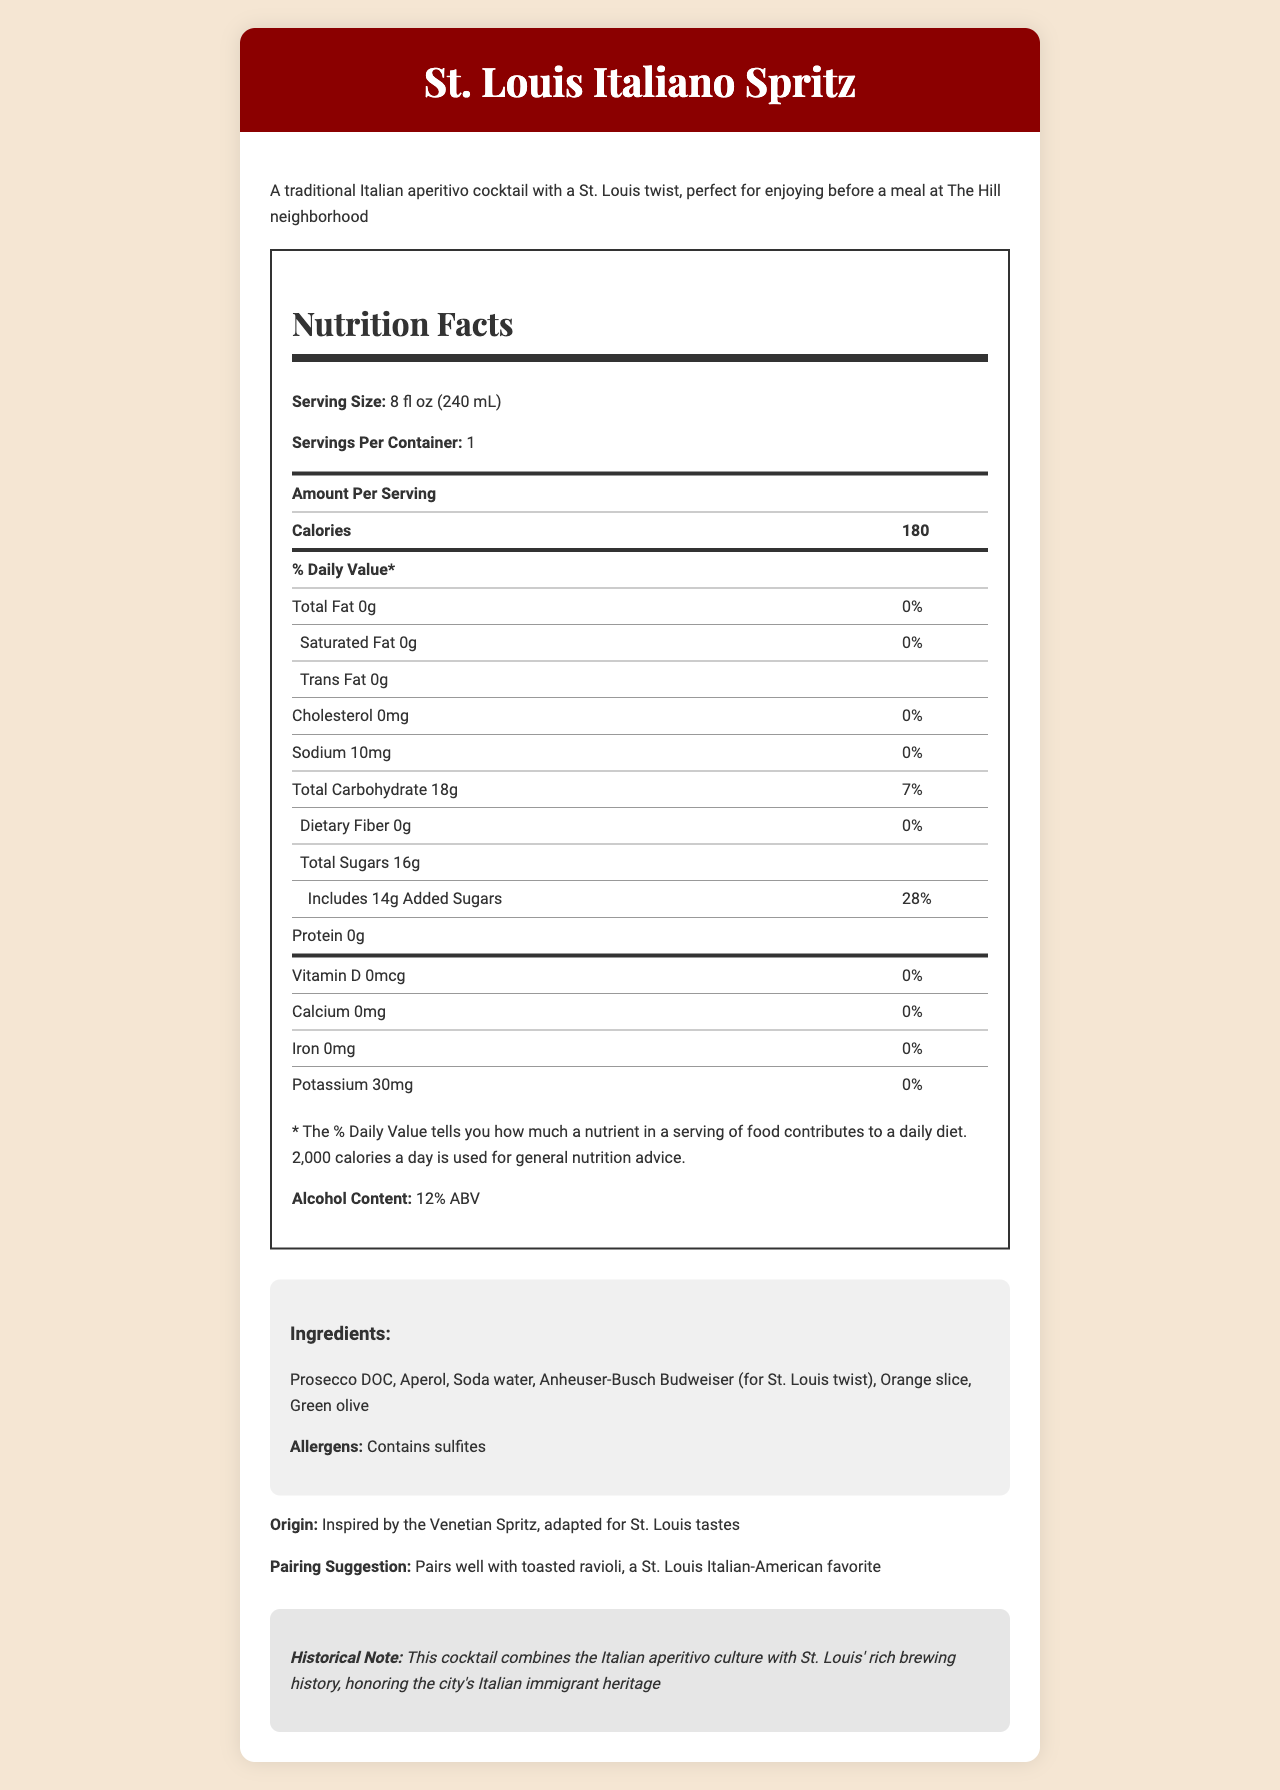what is the serving size? The serving size is specified at the top of the nutrition label as "Serving Size: 8 fl oz (240 mL)".
Answer: 8 fl oz (240 mL) how many calories are in one serving? The Nutrition Facts table lists the calories per serving as 180.
Answer: 180 calories what is the total carbohydrate content per serving? The Nutrition Facts table shows that the Total Carbohydrate content per serving is 18g.
Answer: 18g how much sodium is in each serving? The Nutrition Facts table shows that each serving contains 10 mg of Sodium.
Answer: 10 mg what percentage of the daily value of added sugars is in one serving? The Nutrition Facts table indicates that each serving contains 28% of the daily value for added sugars.
Answer: 28% which ingredient gives the cocktail a St. Louis twist? A. Prosecco DOC B. Aperol C. Anheuser-Busch Budweiser D. Soda water The ingredients list includes "Anheuser-Busch Budweiser (for St. Louis twist)".
Answer: C. Anheuser-Busch Budweiser what is the alcohol content of the cocktail? The "Alcohol Content" section of the Nutrition Facts label states that the alcohol content is 12% ABV.
Answer: 12% ABV does the cocktail contain any protein? The Nutrition Facts table shows that the protein content is 0g, meaning it contains no protein.
Answer: No True or False: The cocktail contains dietary fiber. The Nutrition Facts table shows 0g for Dietary Fiber, meaning it contains no dietary fiber.
Answer: False summarize the main idea of the document The document primarily focuses on the nutritional content, ingredients, and the cultural significance of the "St. Louis Italiano Spritz" cocktail, which merges Italian and St. Louis traditions.
Answer: The document provides the nutritional facts and details for the "St. Louis Italiano Spritz," a cocktail inspired by a traditional Italian aperitivo with a twist from St. Louis. It includes nutrition information, ingredients, and pairing suggestions, and highlights the cultural connection between Italian aperitivo culture and St. Louis' brewing history. when was the cocktail first created? The document does not provide any information regarding the creation date of the cocktail.
Answer: Not enough information 